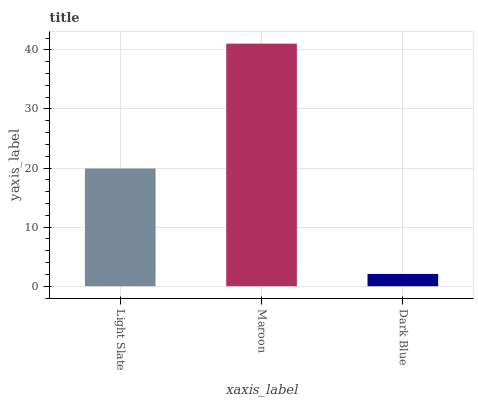Is Dark Blue the minimum?
Answer yes or no. Yes. Is Maroon the maximum?
Answer yes or no. Yes. Is Maroon the minimum?
Answer yes or no. No. Is Dark Blue the maximum?
Answer yes or no. No. Is Maroon greater than Dark Blue?
Answer yes or no. Yes. Is Dark Blue less than Maroon?
Answer yes or no. Yes. Is Dark Blue greater than Maroon?
Answer yes or no. No. Is Maroon less than Dark Blue?
Answer yes or no. No. Is Light Slate the high median?
Answer yes or no. Yes. Is Light Slate the low median?
Answer yes or no. Yes. Is Dark Blue the high median?
Answer yes or no. No. Is Maroon the low median?
Answer yes or no. No. 